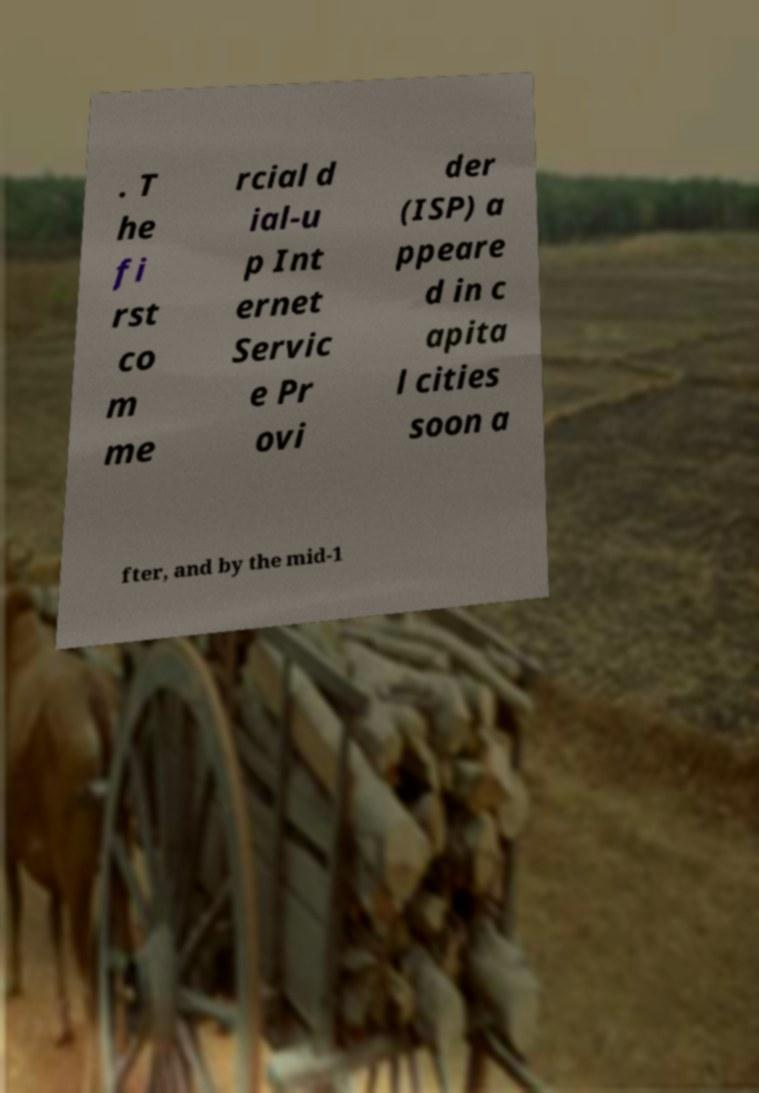Could you assist in decoding the text presented in this image and type it out clearly? . T he fi rst co m me rcial d ial-u p Int ernet Servic e Pr ovi der (ISP) a ppeare d in c apita l cities soon a fter, and by the mid-1 